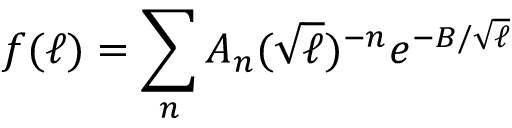Convert formula to latex. <formula><loc_0><loc_0><loc_500><loc_500>f ( \ell ) = \sum _ { n } A _ { n } ( \sqrt { \ell } ) ^ { - n } e ^ { - B / \sqrt { \ell } }</formula> 